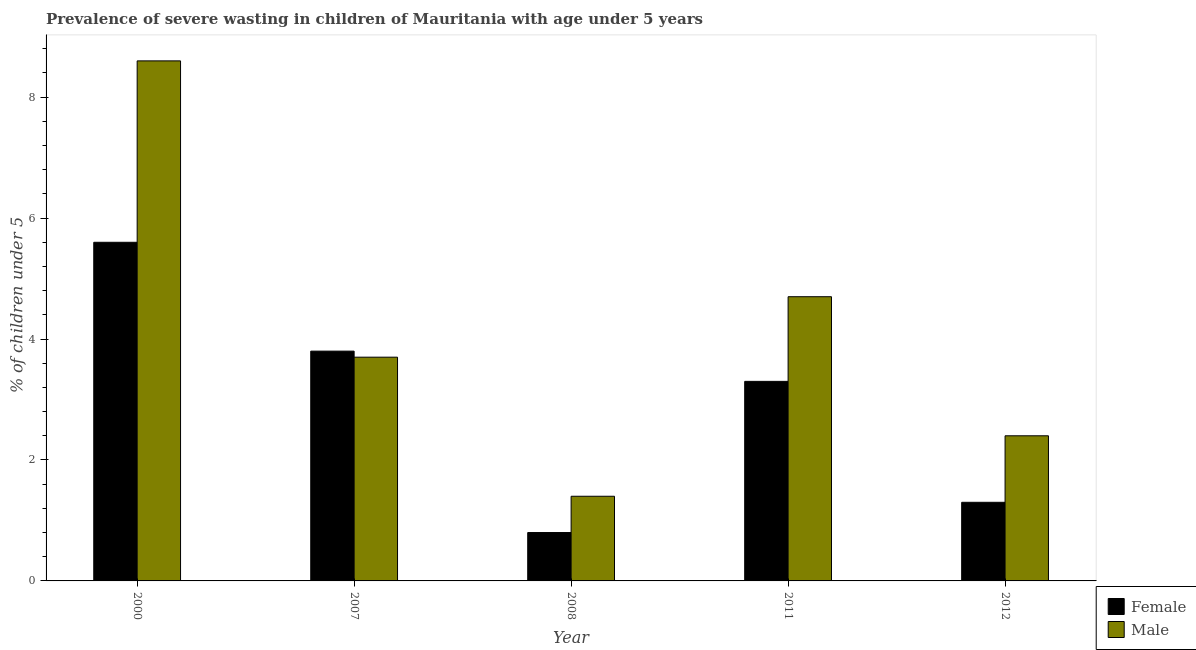Are the number of bars on each tick of the X-axis equal?
Your response must be concise. Yes. How many bars are there on the 1st tick from the left?
Your response must be concise. 2. How many bars are there on the 5th tick from the right?
Provide a succinct answer. 2. What is the percentage of undernourished female children in 2000?
Offer a very short reply. 5.6. Across all years, what is the maximum percentage of undernourished male children?
Provide a short and direct response. 8.6. Across all years, what is the minimum percentage of undernourished male children?
Your answer should be very brief. 1.4. In which year was the percentage of undernourished female children maximum?
Make the answer very short. 2000. In which year was the percentage of undernourished female children minimum?
Give a very brief answer. 2008. What is the total percentage of undernourished male children in the graph?
Your answer should be compact. 20.8. What is the difference between the percentage of undernourished male children in 2007 and that in 2012?
Offer a terse response. 1.3. What is the difference between the percentage of undernourished female children in 2008 and the percentage of undernourished male children in 2007?
Your answer should be compact. -3. What is the average percentage of undernourished female children per year?
Ensure brevity in your answer.  2.96. In the year 2011, what is the difference between the percentage of undernourished female children and percentage of undernourished male children?
Your answer should be compact. 0. What is the ratio of the percentage of undernourished female children in 2011 to that in 2012?
Your response must be concise. 2.54. What is the difference between the highest and the second highest percentage of undernourished male children?
Your response must be concise. 3.9. What is the difference between the highest and the lowest percentage of undernourished female children?
Your answer should be compact. 4.8. In how many years, is the percentage of undernourished female children greater than the average percentage of undernourished female children taken over all years?
Provide a short and direct response. 3. Is the sum of the percentage of undernourished female children in 2007 and 2011 greater than the maximum percentage of undernourished male children across all years?
Give a very brief answer. Yes. How many bars are there?
Keep it short and to the point. 10. Are all the bars in the graph horizontal?
Offer a terse response. No. What is the difference between two consecutive major ticks on the Y-axis?
Your answer should be very brief. 2. Are the values on the major ticks of Y-axis written in scientific E-notation?
Provide a succinct answer. No. Does the graph contain any zero values?
Give a very brief answer. No. Does the graph contain grids?
Provide a succinct answer. No. How many legend labels are there?
Keep it short and to the point. 2. What is the title of the graph?
Ensure brevity in your answer.  Prevalence of severe wasting in children of Mauritania with age under 5 years. Does "Working capital" appear as one of the legend labels in the graph?
Your response must be concise. No. What is the label or title of the X-axis?
Your answer should be very brief. Year. What is the label or title of the Y-axis?
Offer a terse response.  % of children under 5. What is the  % of children under 5 in Female in 2000?
Give a very brief answer. 5.6. What is the  % of children under 5 of Male in 2000?
Your answer should be compact. 8.6. What is the  % of children under 5 of Female in 2007?
Keep it short and to the point. 3.8. What is the  % of children under 5 of Male in 2007?
Your response must be concise. 3.7. What is the  % of children under 5 in Female in 2008?
Your response must be concise. 0.8. What is the  % of children under 5 of Male in 2008?
Your answer should be compact. 1.4. What is the  % of children under 5 in Female in 2011?
Give a very brief answer. 3.3. What is the  % of children under 5 of Male in 2011?
Your answer should be compact. 4.7. What is the  % of children under 5 of Female in 2012?
Give a very brief answer. 1.3. What is the  % of children under 5 in Male in 2012?
Your answer should be compact. 2.4. Across all years, what is the maximum  % of children under 5 of Female?
Your answer should be compact. 5.6. Across all years, what is the maximum  % of children under 5 of Male?
Keep it short and to the point. 8.6. Across all years, what is the minimum  % of children under 5 of Female?
Offer a very short reply. 0.8. Across all years, what is the minimum  % of children under 5 in Male?
Make the answer very short. 1.4. What is the total  % of children under 5 in Male in the graph?
Keep it short and to the point. 20.8. What is the difference between the  % of children under 5 of Female in 2000 and that in 2007?
Make the answer very short. 1.8. What is the difference between the  % of children under 5 in Male in 2000 and that in 2007?
Give a very brief answer. 4.9. What is the difference between the  % of children under 5 in Male in 2000 and that in 2008?
Offer a terse response. 7.2. What is the difference between the  % of children under 5 in Female in 2000 and that in 2011?
Your response must be concise. 2.3. What is the difference between the  % of children under 5 of Male in 2000 and that in 2011?
Offer a terse response. 3.9. What is the difference between the  % of children under 5 of Male in 2000 and that in 2012?
Give a very brief answer. 6.2. What is the difference between the  % of children under 5 of Female in 2007 and that in 2008?
Give a very brief answer. 3. What is the difference between the  % of children under 5 in Female in 2007 and that in 2011?
Keep it short and to the point. 0.5. What is the difference between the  % of children under 5 in Male in 2007 and that in 2011?
Ensure brevity in your answer.  -1. What is the difference between the  % of children under 5 in Female in 2007 and that in 2012?
Your answer should be very brief. 2.5. What is the difference between the  % of children under 5 of Male in 2007 and that in 2012?
Offer a terse response. 1.3. What is the difference between the  % of children under 5 in Female in 2008 and that in 2011?
Your answer should be very brief. -2.5. What is the difference between the  % of children under 5 in Male in 2008 and that in 2011?
Offer a terse response. -3.3. What is the difference between the  % of children under 5 of Male in 2008 and that in 2012?
Make the answer very short. -1. What is the difference between the  % of children under 5 of Female in 2011 and that in 2012?
Provide a short and direct response. 2. What is the difference between the  % of children under 5 of Male in 2011 and that in 2012?
Provide a short and direct response. 2.3. What is the difference between the  % of children under 5 in Female in 2000 and the  % of children under 5 in Male in 2008?
Offer a terse response. 4.2. What is the difference between the  % of children under 5 in Female in 2000 and the  % of children under 5 in Male in 2011?
Give a very brief answer. 0.9. What is the difference between the  % of children under 5 in Female in 2000 and the  % of children under 5 in Male in 2012?
Provide a succinct answer. 3.2. What is the difference between the  % of children under 5 of Female in 2007 and the  % of children under 5 of Male in 2008?
Your answer should be very brief. 2.4. What is the difference between the  % of children under 5 of Female in 2007 and the  % of children under 5 of Male in 2011?
Offer a very short reply. -0.9. What is the difference between the  % of children under 5 of Female in 2007 and the  % of children under 5 of Male in 2012?
Make the answer very short. 1.4. What is the difference between the  % of children under 5 in Female in 2008 and the  % of children under 5 in Male in 2012?
Your answer should be very brief. -1.6. What is the difference between the  % of children under 5 of Female in 2011 and the  % of children under 5 of Male in 2012?
Your answer should be very brief. 0.9. What is the average  % of children under 5 in Female per year?
Your response must be concise. 2.96. What is the average  % of children under 5 in Male per year?
Provide a succinct answer. 4.16. In the year 2007, what is the difference between the  % of children under 5 in Female and  % of children under 5 in Male?
Give a very brief answer. 0.1. In the year 2008, what is the difference between the  % of children under 5 of Female and  % of children under 5 of Male?
Provide a short and direct response. -0.6. In the year 2012, what is the difference between the  % of children under 5 of Female and  % of children under 5 of Male?
Offer a terse response. -1.1. What is the ratio of the  % of children under 5 of Female in 2000 to that in 2007?
Provide a succinct answer. 1.47. What is the ratio of the  % of children under 5 in Male in 2000 to that in 2007?
Give a very brief answer. 2.32. What is the ratio of the  % of children under 5 in Female in 2000 to that in 2008?
Your answer should be compact. 7. What is the ratio of the  % of children under 5 of Male in 2000 to that in 2008?
Keep it short and to the point. 6.14. What is the ratio of the  % of children under 5 in Female in 2000 to that in 2011?
Provide a short and direct response. 1.7. What is the ratio of the  % of children under 5 in Male in 2000 to that in 2011?
Ensure brevity in your answer.  1.83. What is the ratio of the  % of children under 5 in Female in 2000 to that in 2012?
Keep it short and to the point. 4.31. What is the ratio of the  % of children under 5 in Male in 2000 to that in 2012?
Provide a succinct answer. 3.58. What is the ratio of the  % of children under 5 in Female in 2007 to that in 2008?
Give a very brief answer. 4.75. What is the ratio of the  % of children under 5 in Male in 2007 to that in 2008?
Your response must be concise. 2.64. What is the ratio of the  % of children under 5 of Female in 2007 to that in 2011?
Your answer should be very brief. 1.15. What is the ratio of the  % of children under 5 in Male in 2007 to that in 2011?
Provide a short and direct response. 0.79. What is the ratio of the  % of children under 5 in Female in 2007 to that in 2012?
Your response must be concise. 2.92. What is the ratio of the  % of children under 5 in Male in 2007 to that in 2012?
Your answer should be very brief. 1.54. What is the ratio of the  % of children under 5 of Female in 2008 to that in 2011?
Your answer should be very brief. 0.24. What is the ratio of the  % of children under 5 of Male in 2008 to that in 2011?
Offer a very short reply. 0.3. What is the ratio of the  % of children under 5 in Female in 2008 to that in 2012?
Ensure brevity in your answer.  0.62. What is the ratio of the  % of children under 5 of Male in 2008 to that in 2012?
Your response must be concise. 0.58. What is the ratio of the  % of children under 5 in Female in 2011 to that in 2012?
Keep it short and to the point. 2.54. What is the ratio of the  % of children under 5 in Male in 2011 to that in 2012?
Ensure brevity in your answer.  1.96. What is the difference between the highest and the second highest  % of children under 5 in Male?
Give a very brief answer. 3.9. What is the difference between the highest and the lowest  % of children under 5 of Male?
Make the answer very short. 7.2. 